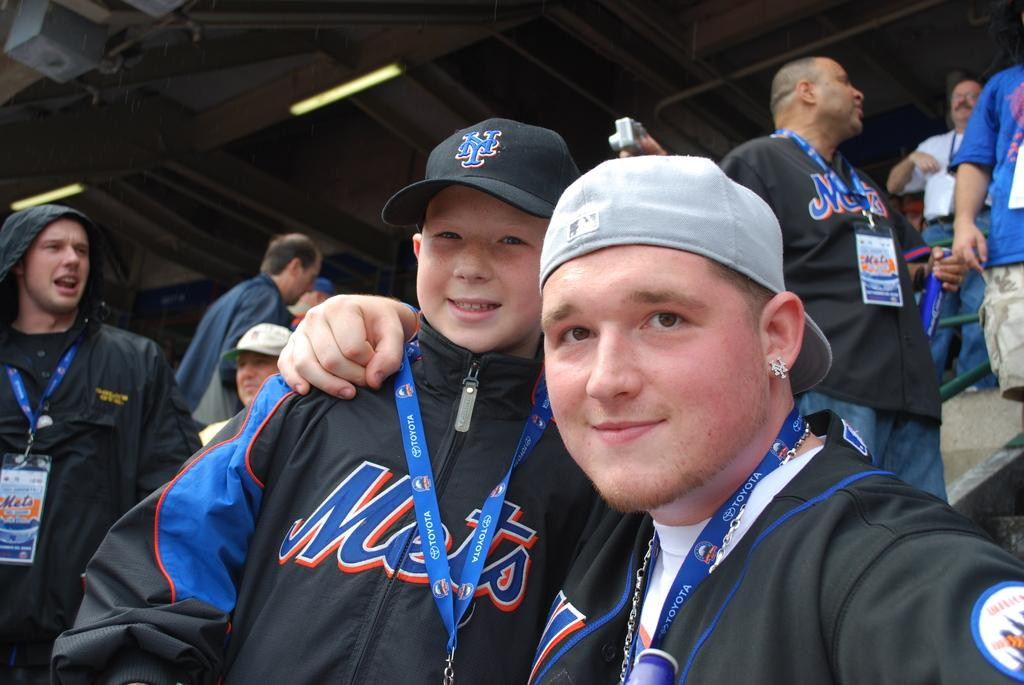<image>
Give a short and clear explanation of the subsequent image. Various people are seen wearing black Mets jackets. 